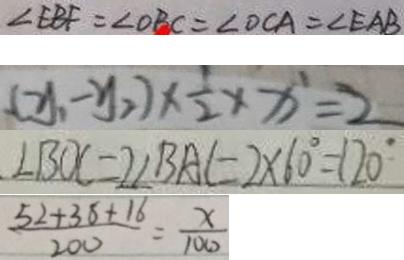Convert formula to latex. <formula><loc_0><loc_0><loc_500><loc_500>\angle E B F = \angle O C A = \angle O B C = \angle E A B 
 ( y _ { 1 } - y _ { 2 } ) \times \frac { 1 } { 2 } \times x ^ { 1 } = 2 
 \angle B O C = 2 \angle B A C = 2 \times 6 0 ^ { \circ } = 1 2 0 ^ { \circ } 
 \frac { 5 2 + 3 8 + 1 6 } { 2 0 0 } = \frac { x } { 1 0 0 }</formula> 